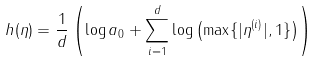Convert formula to latex. <formula><loc_0><loc_0><loc_500><loc_500>h ( \eta ) = \frac { 1 } { d } \left ( \log a _ { 0 } + \sum _ { i = 1 } ^ { d } \log \left ( \max \{ | \eta ^ { ( i ) } | , 1 \} \right ) \right )</formula> 